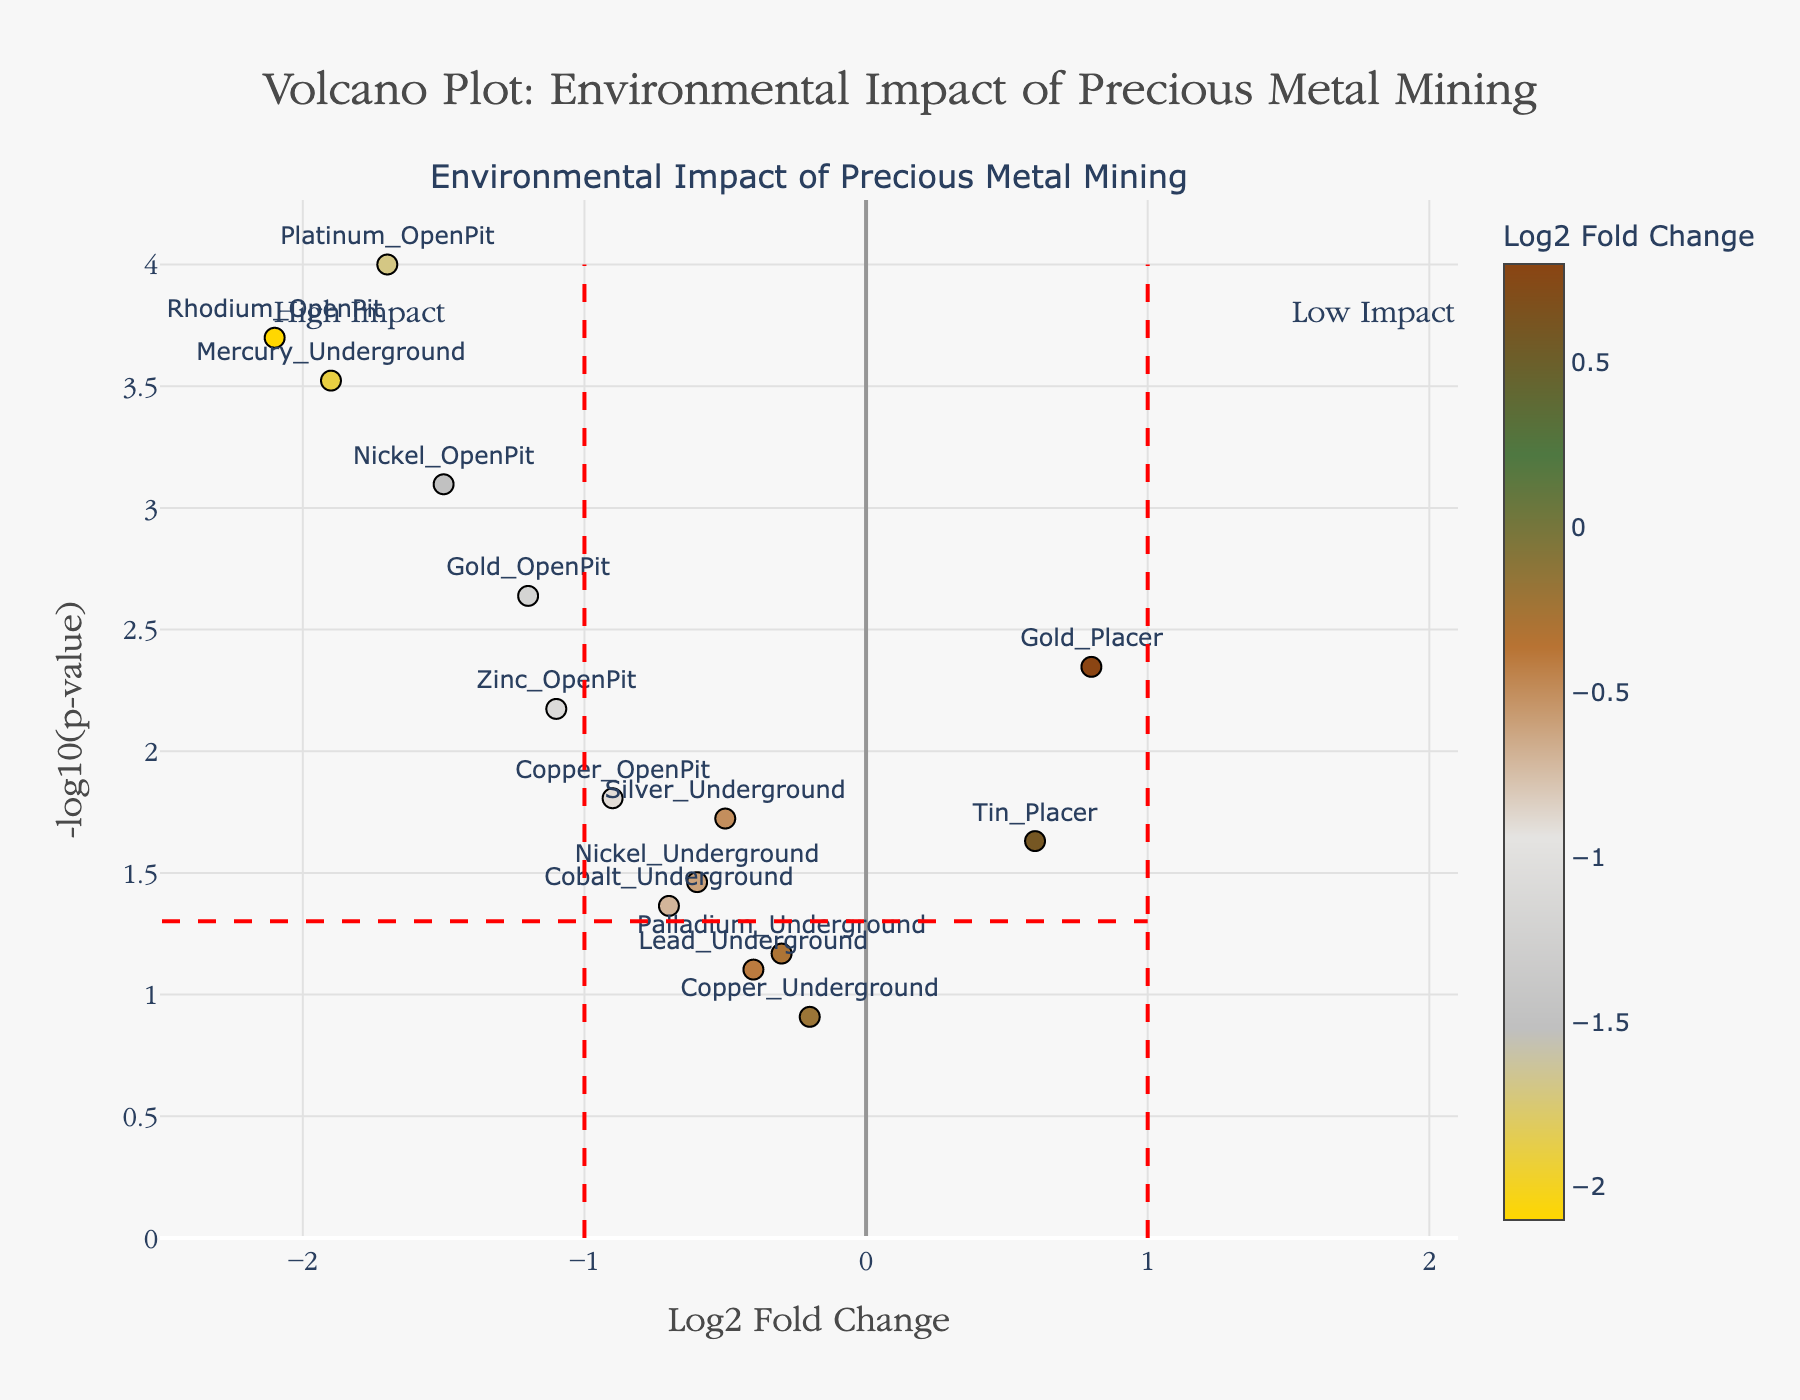What is the title of the plot? The title of the plot is displayed at the top and reads "Volcano Plot: Environmental Impact of Precious Metal Mining".
Answer: "Volcano Plot: Environmental Impact of Precious Metal Mining" How many metals have a negative Log2 Fold Change? By counting the data points on the left side of the vertical line marked at x=0, which represents a negative Log2 Fold Change, there are 11 points.
Answer: 11 Which metal has the lowest p-value? The lowest p-value corresponds to the highest point on the y-axis since we use -log10(p-value). The highest point is for Platinum_OpenPit.
Answer: Platinum_OpenPit Which metal has the highest environmental impact? The highest environmental impact corresponds to the lowest Log2 Fold Change (most negative value), clearly visible on the plot as Rhodium_OpenPit with -2.1.
Answer: Rhodium_OpenPit Which metal has the highest p-value? The highest p-value corresponds to the lowest point on the y-axis for reasonably visible points. The point closest to the x-axis is Copper_Underground with a p-value of 0.1234.
Answer: Copper_Underground How many metals have a -log10(p-value) greater than 2? To find the number of points above y=2, count the data points above this line. There are 8 points above this threshold.
Answer: 8 Which techniques result in a positive Log2 Fold Change? Positive Log2 Fold Change appears to the right of the vertical line at x=0. From the plot, Gold_Placer and Tin_Placer have positive Log2 Fold Change values.
Answer: Gold_Placer, Tin_Placer What is the Log2 Fold Change and p-value for Nickel_OpenPit? From the hover information or the point location, Nickel_OpenPit has a Log2 Fold Change of -1.5 and a p-value of 0.0008.
Answer: Log2 Fold Change: -1.5, p-value: 0.0008 Which metals are shown as the "High Impact"? "High Impact" is annotated on the plot and corresponds to the points left of the vertical line at x=-1 and above the horizontal line at y=-log10(0.05). These include Platinum_OpenPit, Rhodium_OpenPit, Mercury_Underground, and Nickel_OpenPit.
Answer: Platinum_OpenPit, Rhodium_OpenPit, Mercury_Underground, Nickel_OpenPit What is the range of -log10(p-value)? To find the range, check the minimum and maximum y-values. The minimum appears around 0 (for Copper_Underground) and the maximum is approximately 4 (Platinum_OpenPit).
Answer: 0 to 4 